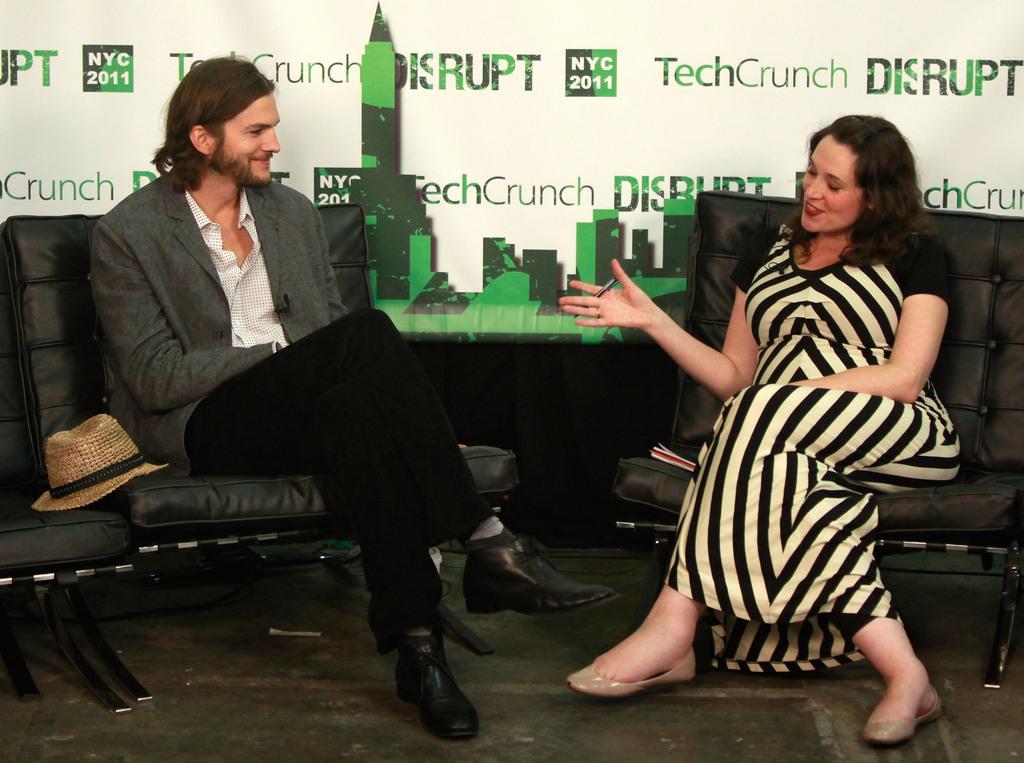Could you give a brief overview of what you see in this image? In this picture we can see a man & a woman sitting on the chairs. The background is green and white color. 